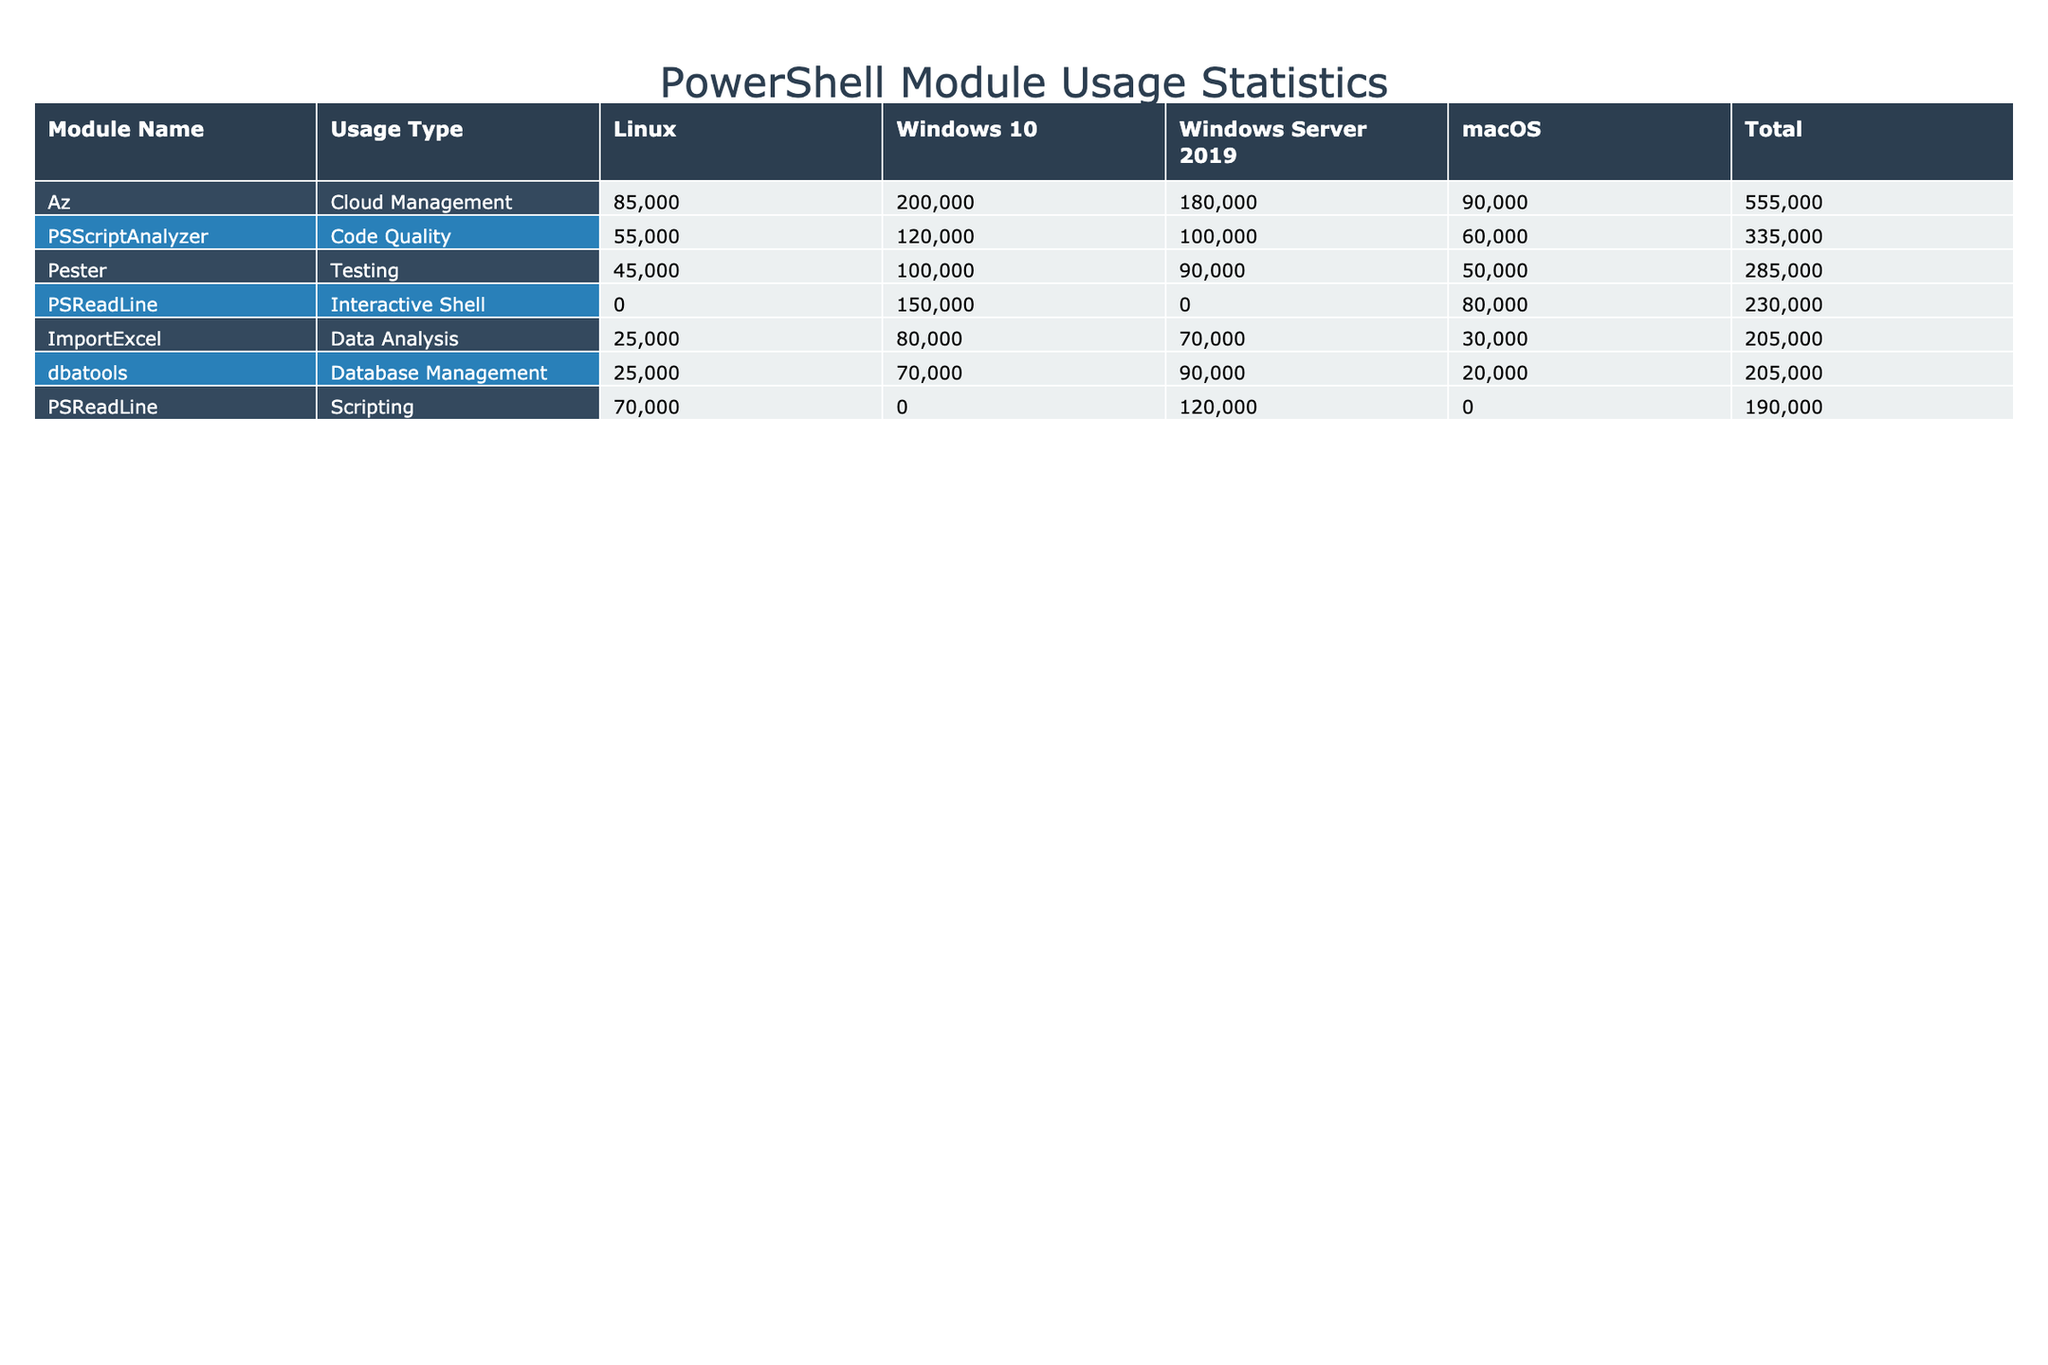What is the total number of downloads for the Az module? By locating the row corresponding to the Az module and summing the downloads across all operating systems, we have 200000 for Windows 10, 180000 for Windows Server 2019, 90000 for macOS, and 85000 for Linux. Adding these gives us 200000 + 180000 + 90000 + 85000 = 555000.
Answer: 555000 Which PowerShell module has the highest rating on macOS? Looking at the macOS column across all modules, PSReadLine has a rating of 4.6, Az has a rating of 4.7, Pester has a rating of 4.5, ImportExcel has a rating of 4.4, PSScriptAnalyzer has a rating of 4.6, and dbatools has a rating of 4.5. The highest rating among these is for Az at 4.7.
Answer: Az How many more downloads does the PSReadLine module have on Windows 10 than on Linux? First, we find the downloads for PSReadLine on Windows 10, which is 150000. Next, we check the downloads for Linux, which is 70000. The difference is 150000 - 70000 = 80000.
Answer: 80000 Is the average rating for the Testing usage type higher than 4.5? We consider the ratings for the Testing usage type: Pester on Windows 10 has 4.7, Windows Server 2019 has 4.6, macOS has 4.5, and Linux has 4.4. To find the average, we add them: 4.7 + 4.6 + 4.5 + 4.4 = 19.2. Then, we divide by the number of entries, which is 4. The average rating is 19.2 / 4 = 4.8, which is higher than 4.5.
Answer: Yes Which operating system has the least total downloads for the ImportExcel module? First, we identify the downloads for ImportExcel: on Windows 10 it has 80000, Windows Server 2019 has 70000, macOS has 30000, and Linux has 25000. Comparing these values, we see that Linux has the least downloads at 25000.
Answer: Linux 